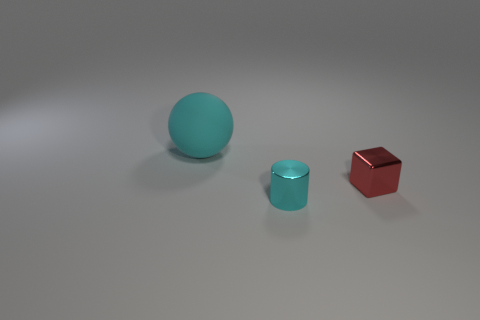Add 3 brown matte spheres. How many objects exist? 6 Subtract all spheres. How many objects are left? 2 Subtract 0 blue cylinders. How many objects are left? 3 Subtract all cyan objects. Subtract all cyan shiny things. How many objects are left? 0 Add 1 spheres. How many spheres are left? 2 Add 3 matte spheres. How many matte spheres exist? 4 